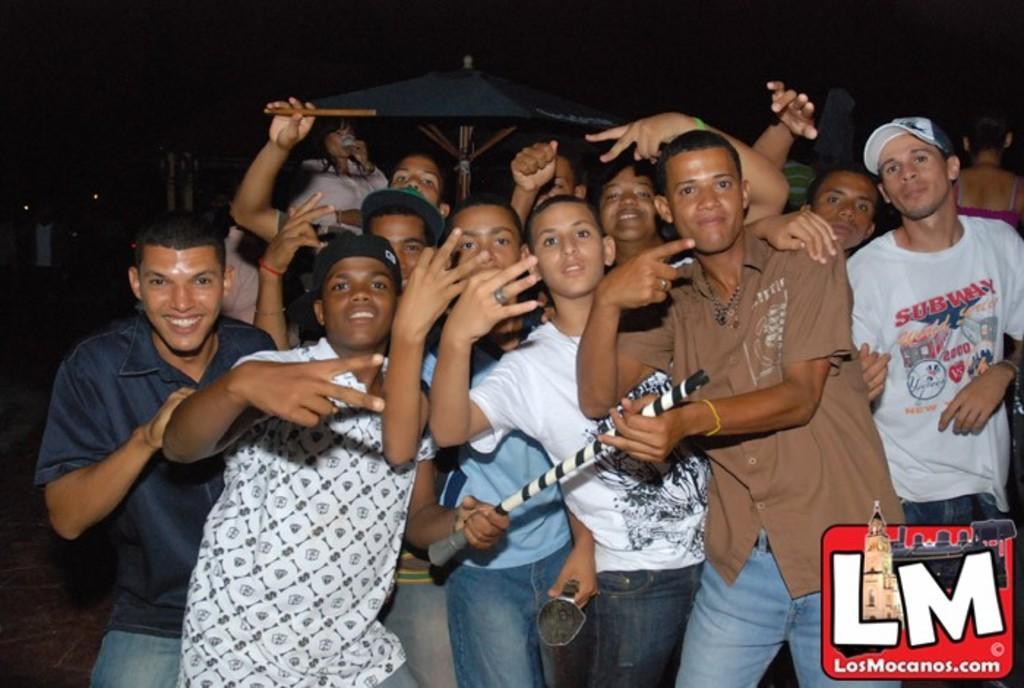How would you summarize this image in a sentence or two? In this image there are many boys. There is a black color umbrella in the back side. 